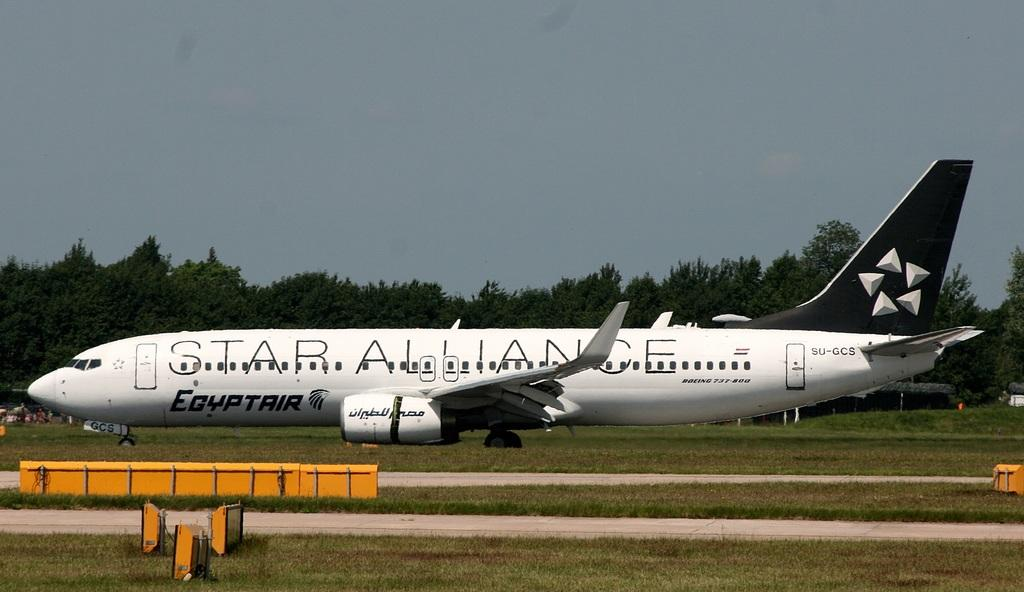<image>
Summarize the visual content of the image. A Star Alliance plane is parked at the airport near some yellow markers. 